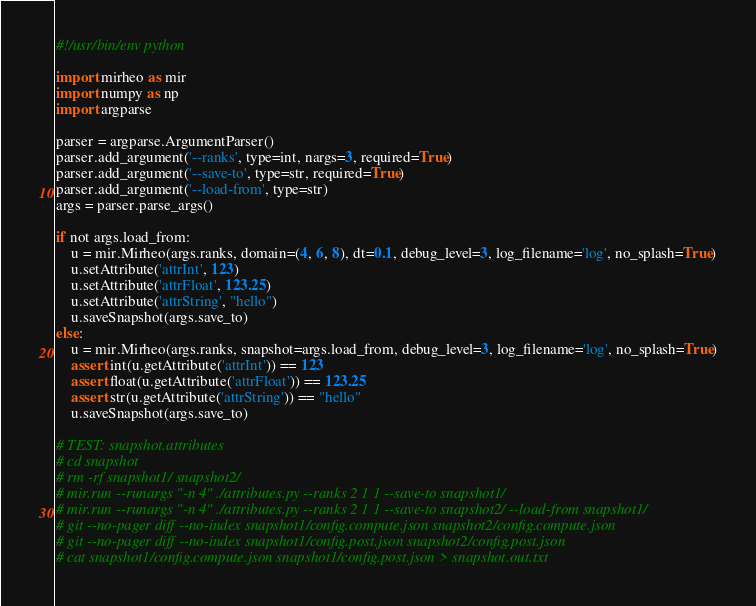Convert code to text. <code><loc_0><loc_0><loc_500><loc_500><_Python_>#!/usr/bin/env python

import mirheo as mir
import numpy as np
import argparse

parser = argparse.ArgumentParser()
parser.add_argument('--ranks', type=int, nargs=3, required=True)
parser.add_argument('--save-to', type=str, required=True)
parser.add_argument('--load-from', type=str)
args = parser.parse_args()

if not args.load_from:
    u = mir.Mirheo(args.ranks, domain=(4, 6, 8), dt=0.1, debug_level=3, log_filename='log', no_splash=True)
    u.setAttribute('attrInt', 123)
    u.setAttribute('attrFloat', 123.25)
    u.setAttribute('attrString', "hello")
    u.saveSnapshot(args.save_to)
else:
    u = mir.Mirheo(args.ranks, snapshot=args.load_from, debug_level=3, log_filename='log', no_splash=True)
    assert int(u.getAttribute('attrInt')) == 123
    assert float(u.getAttribute('attrFloat')) == 123.25
    assert str(u.getAttribute('attrString')) == "hello"
    u.saveSnapshot(args.save_to)

# TEST: snapshot.attributes
# cd snapshot
# rm -rf snapshot1/ snapshot2/
# mir.run --runargs "-n 4" ./attributes.py --ranks 2 1 1 --save-to snapshot1/
# mir.run --runargs "-n 4" ./attributes.py --ranks 2 1 1 --save-to snapshot2/ --load-from snapshot1/
# git --no-pager diff --no-index snapshot1/config.compute.json snapshot2/config.compute.json
# git --no-pager diff --no-index snapshot1/config.post.json snapshot2/config.post.json
# cat snapshot1/config.compute.json snapshot1/config.post.json > snapshot.out.txt
</code> 